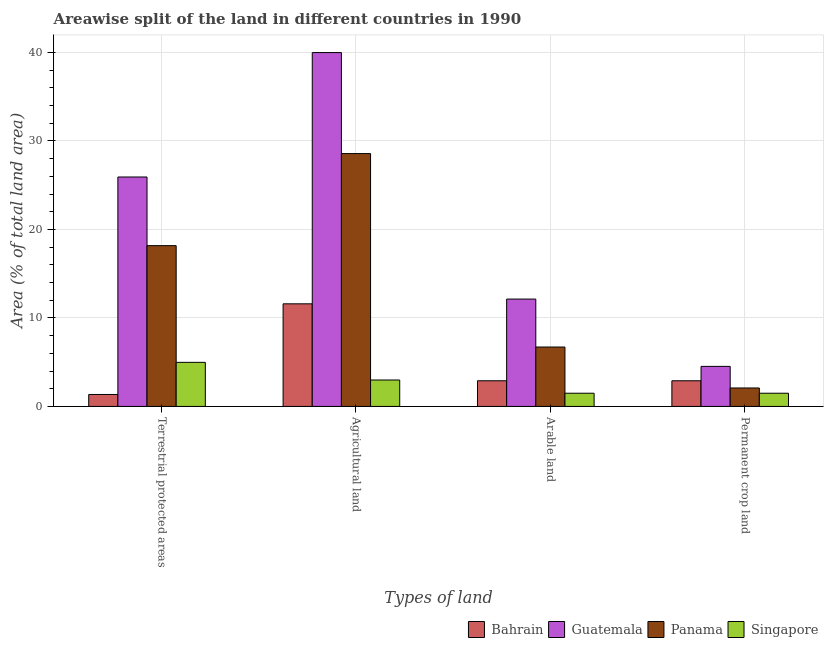How many groups of bars are there?
Make the answer very short. 4. How many bars are there on the 1st tick from the left?
Offer a very short reply. 4. What is the label of the 1st group of bars from the left?
Provide a short and direct response. Terrestrial protected areas. What is the percentage of area under permanent crop land in Singapore?
Provide a succinct answer. 1.49. Across all countries, what is the maximum percentage of land under terrestrial protection?
Ensure brevity in your answer.  25.93. Across all countries, what is the minimum percentage of land under terrestrial protection?
Keep it short and to the point. 1.35. In which country was the percentage of area under arable land maximum?
Provide a succinct answer. Guatemala. In which country was the percentage of area under permanent crop land minimum?
Give a very brief answer. Singapore. What is the total percentage of area under permanent crop land in the graph?
Your answer should be compact. 11. What is the difference between the percentage of area under arable land in Singapore and that in Bahrain?
Provide a succinct answer. -1.41. What is the difference between the percentage of land under terrestrial protection in Bahrain and the percentage of area under agricultural land in Panama?
Offer a very short reply. -27.22. What is the average percentage of area under permanent crop land per country?
Offer a very short reply. 2.75. What is the difference between the percentage of land under terrestrial protection and percentage of area under arable land in Bahrain?
Offer a very short reply. -1.55. In how many countries, is the percentage of area under agricultural land greater than 22 %?
Give a very brief answer. 2. What is the ratio of the percentage of area under agricultural land in Panama to that in Singapore?
Make the answer very short. 9.57. Is the difference between the percentage of land under terrestrial protection in Guatemala and Bahrain greater than the difference between the percentage of area under agricultural land in Guatemala and Bahrain?
Offer a terse response. No. What is the difference between the highest and the second highest percentage of area under arable land?
Your answer should be very brief. 5.42. What is the difference between the highest and the lowest percentage of area under arable land?
Provide a short and direct response. 10.64. In how many countries, is the percentage of area under agricultural land greater than the average percentage of area under agricultural land taken over all countries?
Keep it short and to the point. 2. Is the sum of the percentage of area under agricultural land in Bahrain and Guatemala greater than the maximum percentage of land under terrestrial protection across all countries?
Make the answer very short. Yes. What does the 3rd bar from the left in Agricultural land represents?
Make the answer very short. Panama. What does the 4th bar from the right in Agricultural land represents?
Make the answer very short. Bahrain. How many bars are there?
Make the answer very short. 16. Are all the bars in the graph horizontal?
Give a very brief answer. No. Are the values on the major ticks of Y-axis written in scientific E-notation?
Give a very brief answer. No. Where does the legend appear in the graph?
Make the answer very short. Bottom right. How many legend labels are there?
Your answer should be very brief. 4. How are the legend labels stacked?
Give a very brief answer. Horizontal. What is the title of the graph?
Provide a succinct answer. Areawise split of the land in different countries in 1990. What is the label or title of the X-axis?
Provide a short and direct response. Types of land. What is the label or title of the Y-axis?
Offer a terse response. Area (% of total land area). What is the Area (% of total land area) in Bahrain in Terrestrial protected areas?
Keep it short and to the point. 1.35. What is the Area (% of total land area) in Guatemala in Terrestrial protected areas?
Offer a very short reply. 25.93. What is the Area (% of total land area) in Panama in Terrestrial protected areas?
Provide a short and direct response. 18.17. What is the Area (% of total land area) of Singapore in Terrestrial protected areas?
Keep it short and to the point. 4.98. What is the Area (% of total land area) in Bahrain in Agricultural land?
Provide a succinct answer. 11.59. What is the Area (% of total land area) of Guatemala in Agricultural land?
Provide a short and direct response. 39.99. What is the Area (% of total land area) of Panama in Agricultural land?
Give a very brief answer. 28.57. What is the Area (% of total land area) in Singapore in Agricultural land?
Offer a very short reply. 2.99. What is the Area (% of total land area) of Bahrain in Arable land?
Your answer should be very brief. 2.9. What is the Area (% of total land area) in Guatemala in Arable land?
Your response must be concise. 12.13. What is the Area (% of total land area) in Panama in Arable land?
Your answer should be very brief. 6.71. What is the Area (% of total land area) in Singapore in Arable land?
Give a very brief answer. 1.49. What is the Area (% of total land area) of Bahrain in Permanent crop land?
Ensure brevity in your answer.  2.9. What is the Area (% of total land area) in Guatemala in Permanent crop land?
Offer a terse response. 4.53. What is the Area (% of total land area) in Panama in Permanent crop land?
Offer a very short reply. 2.09. What is the Area (% of total land area) of Singapore in Permanent crop land?
Offer a very short reply. 1.49. Across all Types of land, what is the maximum Area (% of total land area) in Bahrain?
Offer a terse response. 11.59. Across all Types of land, what is the maximum Area (% of total land area) of Guatemala?
Ensure brevity in your answer.  39.99. Across all Types of land, what is the maximum Area (% of total land area) of Panama?
Provide a succinct answer. 28.57. Across all Types of land, what is the maximum Area (% of total land area) of Singapore?
Offer a terse response. 4.98. Across all Types of land, what is the minimum Area (% of total land area) in Bahrain?
Offer a terse response. 1.35. Across all Types of land, what is the minimum Area (% of total land area) of Guatemala?
Your answer should be compact. 4.53. Across all Types of land, what is the minimum Area (% of total land area) in Panama?
Make the answer very short. 2.09. Across all Types of land, what is the minimum Area (% of total land area) of Singapore?
Keep it short and to the point. 1.49. What is the total Area (% of total land area) of Bahrain in the graph?
Ensure brevity in your answer.  18.74. What is the total Area (% of total land area) in Guatemala in the graph?
Your answer should be compact. 82.57. What is the total Area (% of total land area) in Panama in the graph?
Offer a terse response. 55.54. What is the total Area (% of total land area) of Singapore in the graph?
Your response must be concise. 10.95. What is the difference between the Area (% of total land area) in Bahrain in Terrestrial protected areas and that in Agricultural land?
Make the answer very short. -10.24. What is the difference between the Area (% of total land area) in Guatemala in Terrestrial protected areas and that in Agricultural land?
Offer a very short reply. -14.06. What is the difference between the Area (% of total land area) in Panama in Terrestrial protected areas and that in Agricultural land?
Make the answer very short. -10.4. What is the difference between the Area (% of total land area) of Singapore in Terrestrial protected areas and that in Agricultural land?
Your response must be concise. 2. What is the difference between the Area (% of total land area) in Bahrain in Terrestrial protected areas and that in Arable land?
Provide a short and direct response. -1.55. What is the difference between the Area (% of total land area) of Guatemala in Terrestrial protected areas and that in Arable land?
Ensure brevity in your answer.  13.79. What is the difference between the Area (% of total land area) in Panama in Terrestrial protected areas and that in Arable land?
Make the answer very short. 11.46. What is the difference between the Area (% of total land area) in Singapore in Terrestrial protected areas and that in Arable land?
Keep it short and to the point. 3.49. What is the difference between the Area (% of total land area) in Bahrain in Terrestrial protected areas and that in Permanent crop land?
Ensure brevity in your answer.  -1.55. What is the difference between the Area (% of total land area) in Guatemala in Terrestrial protected areas and that in Permanent crop land?
Give a very brief answer. 21.4. What is the difference between the Area (% of total land area) in Panama in Terrestrial protected areas and that in Permanent crop land?
Provide a short and direct response. 16.08. What is the difference between the Area (% of total land area) of Singapore in Terrestrial protected areas and that in Permanent crop land?
Ensure brevity in your answer.  3.49. What is the difference between the Area (% of total land area) in Bahrain in Agricultural land and that in Arable land?
Provide a short and direct response. 8.7. What is the difference between the Area (% of total land area) of Guatemala in Agricultural land and that in Arable land?
Make the answer very short. 27.86. What is the difference between the Area (% of total land area) in Panama in Agricultural land and that in Arable land?
Provide a succinct answer. 21.86. What is the difference between the Area (% of total land area) in Singapore in Agricultural land and that in Arable land?
Your answer should be compact. 1.49. What is the difference between the Area (% of total land area) in Bahrain in Agricultural land and that in Permanent crop land?
Offer a terse response. 8.7. What is the difference between the Area (% of total land area) of Guatemala in Agricultural land and that in Permanent crop land?
Ensure brevity in your answer.  35.46. What is the difference between the Area (% of total land area) of Panama in Agricultural land and that in Permanent crop land?
Ensure brevity in your answer.  26.49. What is the difference between the Area (% of total land area) of Singapore in Agricultural land and that in Permanent crop land?
Make the answer very short. 1.49. What is the difference between the Area (% of total land area) in Bahrain in Arable land and that in Permanent crop land?
Provide a succinct answer. 0. What is the difference between the Area (% of total land area) in Guatemala in Arable land and that in Permanent crop land?
Make the answer very short. 7.61. What is the difference between the Area (% of total land area) of Panama in Arable land and that in Permanent crop land?
Offer a very short reply. 4.63. What is the difference between the Area (% of total land area) in Singapore in Arable land and that in Permanent crop land?
Offer a terse response. 0. What is the difference between the Area (% of total land area) in Bahrain in Terrestrial protected areas and the Area (% of total land area) in Guatemala in Agricultural land?
Your answer should be compact. -38.64. What is the difference between the Area (% of total land area) in Bahrain in Terrestrial protected areas and the Area (% of total land area) in Panama in Agricultural land?
Keep it short and to the point. -27.22. What is the difference between the Area (% of total land area) in Bahrain in Terrestrial protected areas and the Area (% of total land area) in Singapore in Agricultural land?
Provide a succinct answer. -1.64. What is the difference between the Area (% of total land area) of Guatemala in Terrestrial protected areas and the Area (% of total land area) of Panama in Agricultural land?
Make the answer very short. -2.65. What is the difference between the Area (% of total land area) in Guatemala in Terrestrial protected areas and the Area (% of total land area) in Singapore in Agricultural land?
Make the answer very short. 22.94. What is the difference between the Area (% of total land area) of Panama in Terrestrial protected areas and the Area (% of total land area) of Singapore in Agricultural land?
Your answer should be compact. 15.18. What is the difference between the Area (% of total land area) of Bahrain in Terrestrial protected areas and the Area (% of total land area) of Guatemala in Arable land?
Provide a succinct answer. -10.78. What is the difference between the Area (% of total land area) of Bahrain in Terrestrial protected areas and the Area (% of total land area) of Panama in Arable land?
Make the answer very short. -5.36. What is the difference between the Area (% of total land area) of Bahrain in Terrestrial protected areas and the Area (% of total land area) of Singapore in Arable land?
Give a very brief answer. -0.14. What is the difference between the Area (% of total land area) in Guatemala in Terrestrial protected areas and the Area (% of total land area) in Panama in Arable land?
Your answer should be very brief. 19.21. What is the difference between the Area (% of total land area) of Guatemala in Terrestrial protected areas and the Area (% of total land area) of Singapore in Arable land?
Your answer should be very brief. 24.43. What is the difference between the Area (% of total land area) of Panama in Terrestrial protected areas and the Area (% of total land area) of Singapore in Arable land?
Make the answer very short. 16.68. What is the difference between the Area (% of total land area) in Bahrain in Terrestrial protected areas and the Area (% of total land area) in Guatemala in Permanent crop land?
Make the answer very short. -3.18. What is the difference between the Area (% of total land area) of Bahrain in Terrestrial protected areas and the Area (% of total land area) of Panama in Permanent crop land?
Keep it short and to the point. -0.73. What is the difference between the Area (% of total land area) of Bahrain in Terrestrial protected areas and the Area (% of total land area) of Singapore in Permanent crop land?
Offer a very short reply. -0.14. What is the difference between the Area (% of total land area) of Guatemala in Terrestrial protected areas and the Area (% of total land area) of Panama in Permanent crop land?
Provide a short and direct response. 23.84. What is the difference between the Area (% of total land area) of Guatemala in Terrestrial protected areas and the Area (% of total land area) of Singapore in Permanent crop land?
Provide a succinct answer. 24.43. What is the difference between the Area (% of total land area) in Panama in Terrestrial protected areas and the Area (% of total land area) in Singapore in Permanent crop land?
Give a very brief answer. 16.68. What is the difference between the Area (% of total land area) in Bahrain in Agricultural land and the Area (% of total land area) in Guatemala in Arable land?
Keep it short and to the point. -0.54. What is the difference between the Area (% of total land area) of Bahrain in Agricultural land and the Area (% of total land area) of Panama in Arable land?
Offer a very short reply. 4.88. What is the difference between the Area (% of total land area) of Bahrain in Agricultural land and the Area (% of total land area) of Singapore in Arable land?
Provide a short and direct response. 10.1. What is the difference between the Area (% of total land area) of Guatemala in Agricultural land and the Area (% of total land area) of Panama in Arable land?
Give a very brief answer. 33.27. What is the difference between the Area (% of total land area) of Guatemala in Agricultural land and the Area (% of total land area) of Singapore in Arable land?
Provide a short and direct response. 38.49. What is the difference between the Area (% of total land area) of Panama in Agricultural land and the Area (% of total land area) of Singapore in Arable land?
Make the answer very short. 27.08. What is the difference between the Area (% of total land area) in Bahrain in Agricultural land and the Area (% of total land area) in Guatemala in Permanent crop land?
Make the answer very short. 7.07. What is the difference between the Area (% of total land area) in Bahrain in Agricultural land and the Area (% of total land area) in Panama in Permanent crop land?
Your answer should be compact. 9.51. What is the difference between the Area (% of total land area) of Bahrain in Agricultural land and the Area (% of total land area) of Singapore in Permanent crop land?
Provide a short and direct response. 10.1. What is the difference between the Area (% of total land area) in Guatemala in Agricultural land and the Area (% of total land area) in Panama in Permanent crop land?
Ensure brevity in your answer.  37.9. What is the difference between the Area (% of total land area) in Guatemala in Agricultural land and the Area (% of total land area) in Singapore in Permanent crop land?
Give a very brief answer. 38.49. What is the difference between the Area (% of total land area) in Panama in Agricultural land and the Area (% of total land area) in Singapore in Permanent crop land?
Offer a terse response. 27.08. What is the difference between the Area (% of total land area) in Bahrain in Arable land and the Area (% of total land area) in Guatemala in Permanent crop land?
Ensure brevity in your answer.  -1.63. What is the difference between the Area (% of total land area) in Bahrain in Arable land and the Area (% of total land area) in Panama in Permanent crop land?
Offer a terse response. 0.81. What is the difference between the Area (% of total land area) in Bahrain in Arable land and the Area (% of total land area) in Singapore in Permanent crop land?
Make the answer very short. 1.41. What is the difference between the Area (% of total land area) of Guatemala in Arable land and the Area (% of total land area) of Panama in Permanent crop land?
Provide a short and direct response. 10.05. What is the difference between the Area (% of total land area) of Guatemala in Arable land and the Area (% of total land area) of Singapore in Permanent crop land?
Offer a very short reply. 10.64. What is the difference between the Area (% of total land area) in Panama in Arable land and the Area (% of total land area) in Singapore in Permanent crop land?
Offer a very short reply. 5.22. What is the average Area (% of total land area) of Bahrain per Types of land?
Ensure brevity in your answer.  4.69. What is the average Area (% of total land area) of Guatemala per Types of land?
Provide a succinct answer. 20.64. What is the average Area (% of total land area) in Panama per Types of land?
Provide a succinct answer. 13.88. What is the average Area (% of total land area) of Singapore per Types of land?
Your response must be concise. 2.74. What is the difference between the Area (% of total land area) in Bahrain and Area (% of total land area) in Guatemala in Terrestrial protected areas?
Offer a terse response. -24.58. What is the difference between the Area (% of total land area) of Bahrain and Area (% of total land area) of Panama in Terrestrial protected areas?
Your answer should be compact. -16.82. What is the difference between the Area (% of total land area) in Bahrain and Area (% of total land area) in Singapore in Terrestrial protected areas?
Make the answer very short. -3.63. What is the difference between the Area (% of total land area) in Guatemala and Area (% of total land area) in Panama in Terrestrial protected areas?
Provide a succinct answer. 7.76. What is the difference between the Area (% of total land area) of Guatemala and Area (% of total land area) of Singapore in Terrestrial protected areas?
Your response must be concise. 20.94. What is the difference between the Area (% of total land area) in Panama and Area (% of total land area) in Singapore in Terrestrial protected areas?
Your response must be concise. 13.19. What is the difference between the Area (% of total land area) in Bahrain and Area (% of total land area) in Guatemala in Agricultural land?
Provide a succinct answer. -28.39. What is the difference between the Area (% of total land area) of Bahrain and Area (% of total land area) of Panama in Agricultural land?
Give a very brief answer. -16.98. What is the difference between the Area (% of total land area) in Bahrain and Area (% of total land area) in Singapore in Agricultural land?
Keep it short and to the point. 8.61. What is the difference between the Area (% of total land area) in Guatemala and Area (% of total land area) in Panama in Agricultural land?
Offer a terse response. 11.42. What is the difference between the Area (% of total land area) of Guatemala and Area (% of total land area) of Singapore in Agricultural land?
Your answer should be very brief. 37. What is the difference between the Area (% of total land area) of Panama and Area (% of total land area) of Singapore in Agricultural land?
Ensure brevity in your answer.  25.59. What is the difference between the Area (% of total land area) of Bahrain and Area (% of total land area) of Guatemala in Arable land?
Make the answer very short. -9.23. What is the difference between the Area (% of total land area) in Bahrain and Area (% of total land area) in Panama in Arable land?
Your answer should be compact. -3.81. What is the difference between the Area (% of total land area) of Bahrain and Area (% of total land area) of Singapore in Arable land?
Provide a succinct answer. 1.41. What is the difference between the Area (% of total land area) of Guatemala and Area (% of total land area) of Panama in Arable land?
Offer a terse response. 5.42. What is the difference between the Area (% of total land area) in Guatemala and Area (% of total land area) in Singapore in Arable land?
Your response must be concise. 10.64. What is the difference between the Area (% of total land area) in Panama and Area (% of total land area) in Singapore in Arable land?
Your answer should be very brief. 5.22. What is the difference between the Area (% of total land area) in Bahrain and Area (% of total land area) in Guatemala in Permanent crop land?
Ensure brevity in your answer.  -1.63. What is the difference between the Area (% of total land area) in Bahrain and Area (% of total land area) in Panama in Permanent crop land?
Your response must be concise. 0.81. What is the difference between the Area (% of total land area) of Bahrain and Area (% of total land area) of Singapore in Permanent crop land?
Keep it short and to the point. 1.41. What is the difference between the Area (% of total land area) in Guatemala and Area (% of total land area) in Panama in Permanent crop land?
Provide a short and direct response. 2.44. What is the difference between the Area (% of total land area) in Guatemala and Area (% of total land area) in Singapore in Permanent crop land?
Your answer should be very brief. 3.03. What is the difference between the Area (% of total land area) of Panama and Area (% of total land area) of Singapore in Permanent crop land?
Provide a succinct answer. 0.59. What is the ratio of the Area (% of total land area) of Bahrain in Terrestrial protected areas to that in Agricultural land?
Keep it short and to the point. 0.12. What is the ratio of the Area (% of total land area) in Guatemala in Terrestrial protected areas to that in Agricultural land?
Provide a succinct answer. 0.65. What is the ratio of the Area (% of total land area) of Panama in Terrestrial protected areas to that in Agricultural land?
Give a very brief answer. 0.64. What is the ratio of the Area (% of total land area) of Singapore in Terrestrial protected areas to that in Agricultural land?
Offer a very short reply. 1.67. What is the ratio of the Area (% of total land area) in Bahrain in Terrestrial protected areas to that in Arable land?
Your response must be concise. 0.47. What is the ratio of the Area (% of total land area) in Guatemala in Terrestrial protected areas to that in Arable land?
Provide a succinct answer. 2.14. What is the ratio of the Area (% of total land area) of Panama in Terrestrial protected areas to that in Arable land?
Provide a succinct answer. 2.71. What is the ratio of the Area (% of total land area) of Singapore in Terrestrial protected areas to that in Arable land?
Your answer should be very brief. 3.34. What is the ratio of the Area (% of total land area) of Bahrain in Terrestrial protected areas to that in Permanent crop land?
Give a very brief answer. 0.47. What is the ratio of the Area (% of total land area) of Guatemala in Terrestrial protected areas to that in Permanent crop land?
Ensure brevity in your answer.  5.73. What is the ratio of the Area (% of total land area) of Panama in Terrestrial protected areas to that in Permanent crop land?
Your response must be concise. 8.71. What is the ratio of the Area (% of total land area) of Singapore in Terrestrial protected areas to that in Permanent crop land?
Offer a very short reply. 3.34. What is the ratio of the Area (% of total land area) of Guatemala in Agricultural land to that in Arable land?
Make the answer very short. 3.3. What is the ratio of the Area (% of total land area) in Panama in Agricultural land to that in Arable land?
Provide a succinct answer. 4.26. What is the ratio of the Area (% of total land area) of Singapore in Agricultural land to that in Arable land?
Offer a very short reply. 2. What is the ratio of the Area (% of total land area) in Bahrain in Agricultural land to that in Permanent crop land?
Give a very brief answer. 4. What is the ratio of the Area (% of total land area) of Guatemala in Agricultural land to that in Permanent crop land?
Offer a terse response. 8.84. What is the ratio of the Area (% of total land area) of Panama in Agricultural land to that in Permanent crop land?
Ensure brevity in your answer.  13.7. What is the ratio of the Area (% of total land area) in Singapore in Agricultural land to that in Permanent crop land?
Offer a very short reply. 2. What is the ratio of the Area (% of total land area) of Guatemala in Arable land to that in Permanent crop land?
Provide a succinct answer. 2.68. What is the ratio of the Area (% of total land area) of Panama in Arable land to that in Permanent crop land?
Offer a terse response. 3.22. What is the ratio of the Area (% of total land area) in Singapore in Arable land to that in Permanent crop land?
Give a very brief answer. 1. What is the difference between the highest and the second highest Area (% of total land area) of Bahrain?
Offer a terse response. 8.7. What is the difference between the highest and the second highest Area (% of total land area) in Guatemala?
Your answer should be compact. 14.06. What is the difference between the highest and the second highest Area (% of total land area) in Panama?
Provide a succinct answer. 10.4. What is the difference between the highest and the second highest Area (% of total land area) of Singapore?
Offer a very short reply. 2. What is the difference between the highest and the lowest Area (% of total land area) of Bahrain?
Give a very brief answer. 10.24. What is the difference between the highest and the lowest Area (% of total land area) of Guatemala?
Ensure brevity in your answer.  35.46. What is the difference between the highest and the lowest Area (% of total land area) of Panama?
Offer a terse response. 26.49. What is the difference between the highest and the lowest Area (% of total land area) of Singapore?
Make the answer very short. 3.49. 